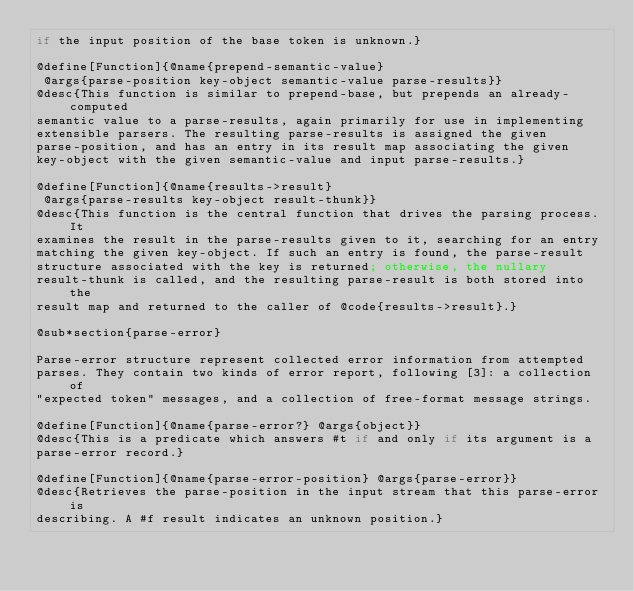<code> <loc_0><loc_0><loc_500><loc_500><_Racket_>if the input position of the base token is unknown.}

@define[Function]{@name{prepend-semantic-value}
 @args{parse-position key-object semantic-value parse-results}}
@desc{This function is similar to prepend-base, but prepends an already-computed
semantic value to a parse-results, again primarily for use in implementing
extensible parsers. The resulting parse-results is assigned the given
parse-position, and has an entry in its result map associating the given
key-object with the given semantic-value and input parse-results.}

@define[Function]{@name{results->result}
 @args{parse-results key-object result-thunk}}
@desc{This function is the central function that drives the parsing process. It
examines the result in the parse-results given to it, searching for an entry
matching the given key-object. If such an entry is found, the parse-result
structure associated with the key is returned; otherwise, the nullary
result-thunk is called, and the resulting parse-result is both stored into the
result map and returned to the caller of @code{results->result}.}

@sub*section{parse-error}

Parse-error structure represent collected error information from attempted
parses. They contain two kinds of error report, following [3]: a collection of
"expected token" messages, and a collection of free-format message strings.

@define[Function]{@name{parse-error?} @args{object}}
@desc{This is a predicate which answers #t if and only if its argument is a
parse-error record.}

@define[Function]{@name{parse-error-position} @args{parse-error}}
@desc{Retrieves the parse-position in the input stream that this parse-error is
describing. A #f result indicates an unknown position.}
</code> 